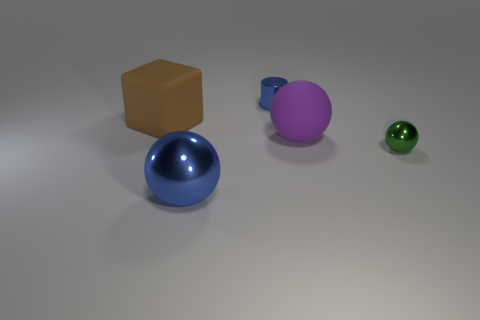Subtract all gray spheres. Subtract all red cylinders. How many spheres are left? 3 Subtract all yellow spheres. How many yellow cubes are left? 0 Add 3 reds. How many small things exist? 0 Subtract all green spheres. Subtract all small metallic balls. How many objects are left? 3 Add 4 brown blocks. How many brown blocks are left? 5 Add 4 shiny objects. How many shiny objects exist? 7 Add 4 tiny blue shiny cylinders. How many objects exist? 9 Subtract all green spheres. How many spheres are left? 2 Subtract all purple rubber spheres. How many spheres are left? 2 Subtract 0 yellow cylinders. How many objects are left? 5 